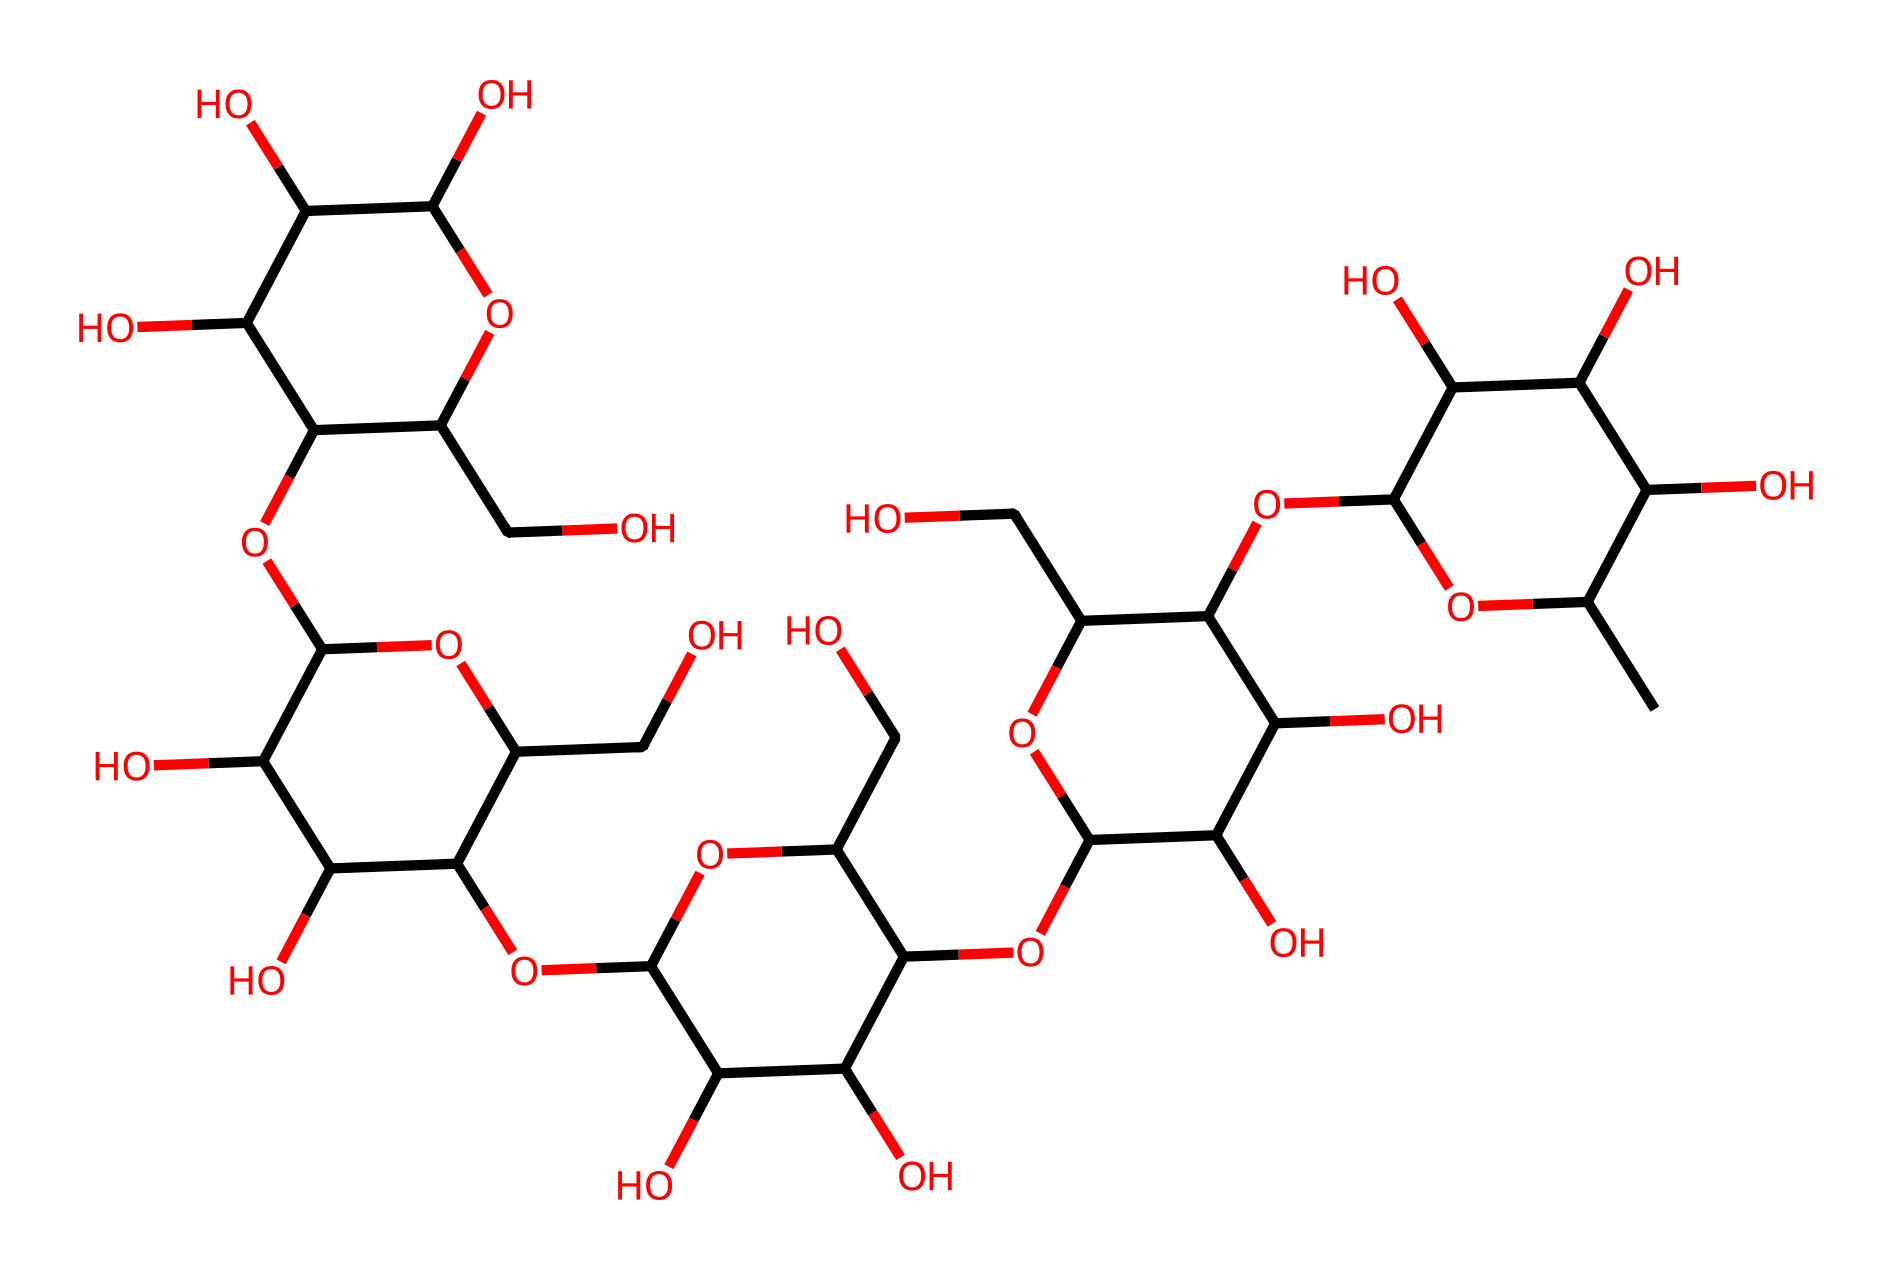What is the name of this chemical? The chemical structure corresponds to xanthan gum, which is known for its use as a thickener and stabilizer in food products, particularly salad dressings.
Answer: xanthan gum How many carbon atoms are present in this structure? By counting the carbon atoms visible in the structure (each carbon typically shown as a vertex in the molecular structure), there are a total of 31 carbon atoms identified in the SMILES representation.
Answer: 31 What is the predominant functional group in xanthan gum? Xanthan gum primarily consists of hydroxyl (-OH) groups, which are responsible for its hydrophilic properties and ability to form gels, enhancing the viscosity of non-Newtonian fluids like salad dressings.
Answer: hydroxyl How does xanthan gum contribute to the viscosity of salad dressings? Xanthan gum interacts with water molecules through hydrogen bonding, creating a network that increases resistance to flow, thus making the dressing a non-Newtonian fluid with shear-thinning properties that can change viscosity under stress.
Answer: viscosity network What type of fluid behavior does xanthan gum exhibit in salad dressings? Xanthan gum exhibits shear-thinning behavior, meaning its viscosity decreases under shear stress, allowing for easier pouring and coating properties while maintaining thickness at rest.
Answer: shear-thinning What is the molar mass of xanthan gum? The calculated molar mass based on its structural formula is approximately 1,100 g/mol, which relates to the overall size and complexity of the xanthan gum molecule.
Answer: 1,100 g/mol 